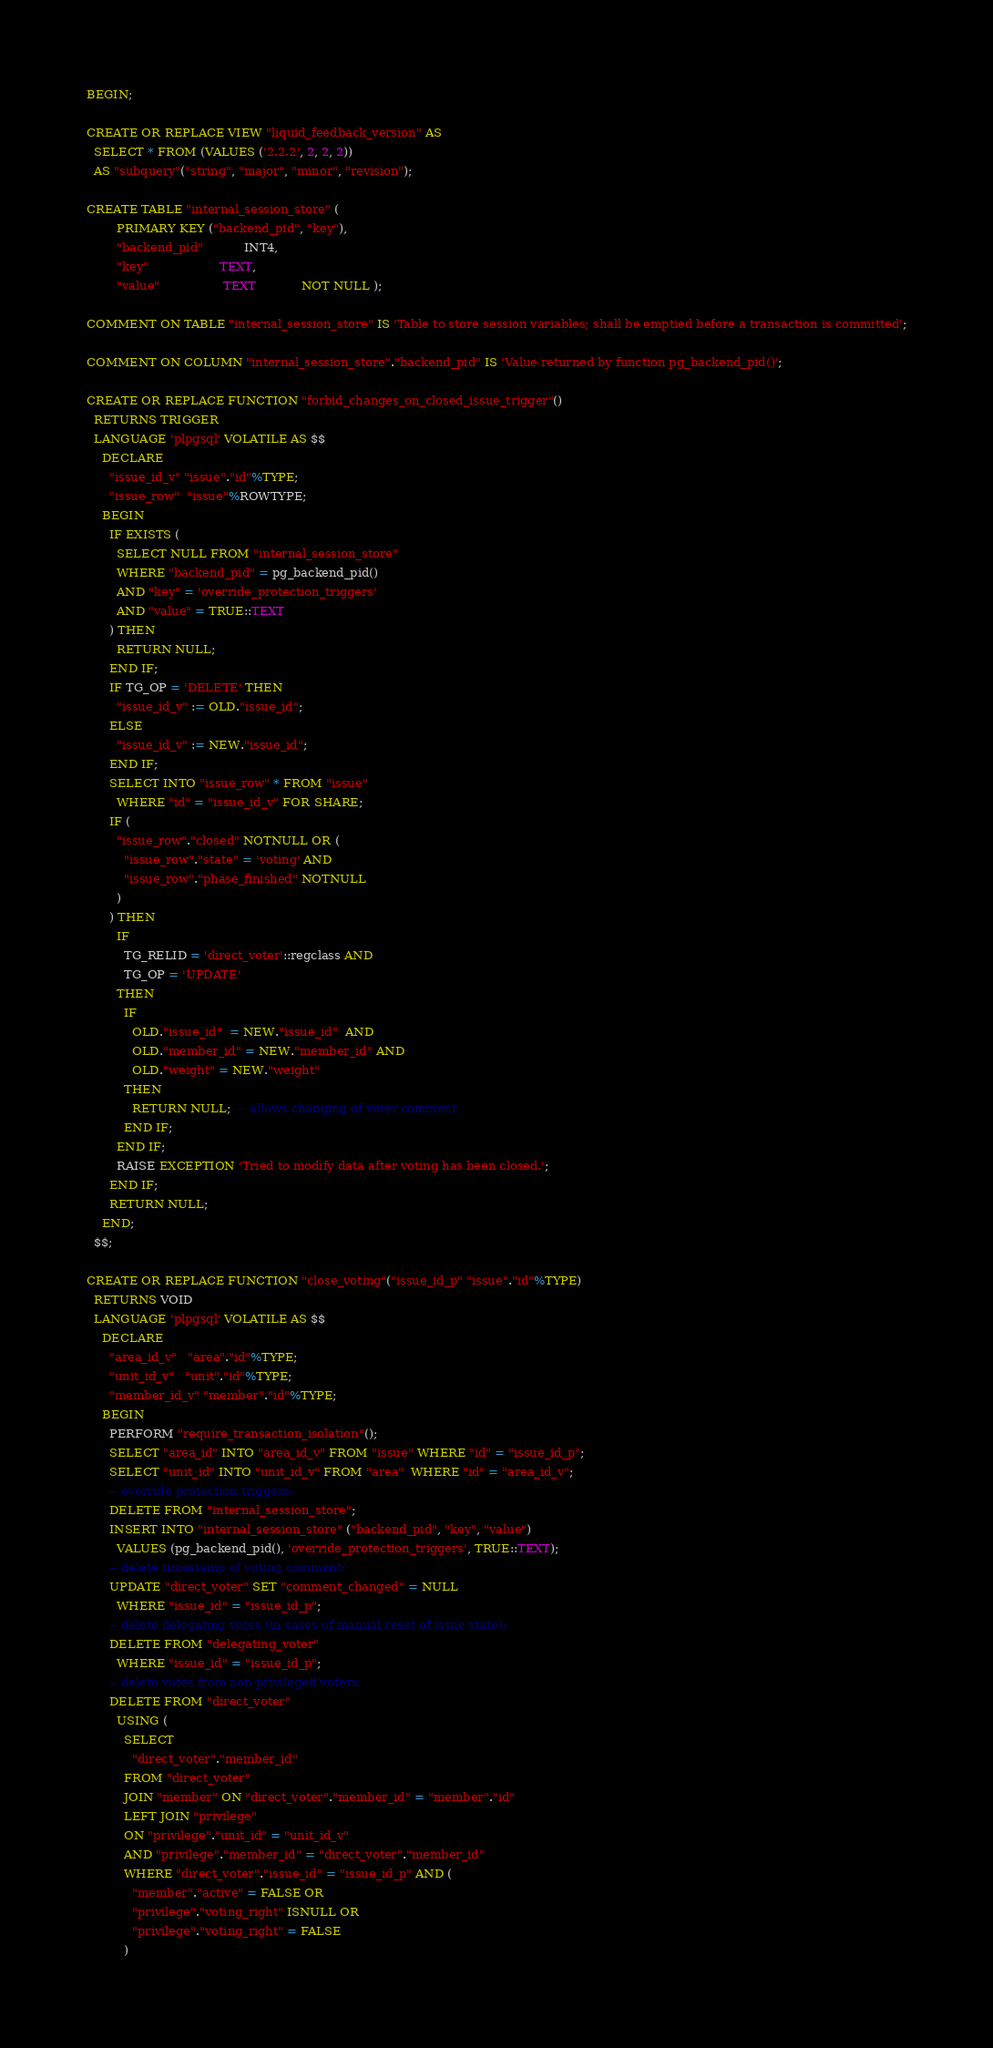<code> <loc_0><loc_0><loc_500><loc_500><_SQL_>BEGIN;

CREATE OR REPLACE VIEW "liquid_feedback_version" AS
  SELECT * FROM (VALUES ('2.2.2', 2, 2, 2))
  AS "subquery"("string", "major", "minor", "revision");

CREATE TABLE "internal_session_store" (
        PRIMARY KEY ("backend_pid", "key"),
        "backend_pid"           INT4,
        "key"                   TEXT,
        "value"                 TEXT            NOT NULL );

COMMENT ON TABLE "internal_session_store" IS 'Table to store session variables; shall be emptied before a transaction is committed';

COMMENT ON COLUMN "internal_session_store"."backend_pid" IS 'Value returned by function pg_backend_pid()';

CREATE OR REPLACE FUNCTION "forbid_changes_on_closed_issue_trigger"()
  RETURNS TRIGGER
  LANGUAGE 'plpgsql' VOLATILE AS $$
    DECLARE
      "issue_id_v" "issue"."id"%TYPE;
      "issue_row"  "issue"%ROWTYPE;
    BEGIN
      IF EXISTS (
        SELECT NULL FROM "internal_session_store"
        WHERE "backend_pid" = pg_backend_pid()
        AND "key" = 'override_protection_triggers'
        AND "value" = TRUE::TEXT
      ) THEN
        RETURN NULL;
      END IF;
      IF TG_OP = 'DELETE' THEN
        "issue_id_v" := OLD."issue_id";
      ELSE
        "issue_id_v" := NEW."issue_id";
      END IF;
      SELECT INTO "issue_row" * FROM "issue"
        WHERE "id" = "issue_id_v" FOR SHARE;
      IF (
        "issue_row"."closed" NOTNULL OR (
          "issue_row"."state" = 'voting' AND
          "issue_row"."phase_finished" NOTNULL
        )
      ) THEN
        IF
          TG_RELID = 'direct_voter'::regclass AND
          TG_OP = 'UPDATE'
        THEN
          IF
            OLD."issue_id"  = NEW."issue_id"  AND
            OLD."member_id" = NEW."member_id" AND
            OLD."weight" = NEW."weight"
          THEN
            RETURN NULL;  -- allows changing of voter comment
          END IF;
        END IF;
        RAISE EXCEPTION 'Tried to modify data after voting has been closed.';
      END IF;
      RETURN NULL;
    END;
  $$;

CREATE OR REPLACE FUNCTION "close_voting"("issue_id_p" "issue"."id"%TYPE)
  RETURNS VOID
  LANGUAGE 'plpgsql' VOLATILE AS $$
    DECLARE
      "area_id_v"   "area"."id"%TYPE;
      "unit_id_v"   "unit"."id"%TYPE;
      "member_id_v" "member"."id"%TYPE;
    BEGIN
      PERFORM "require_transaction_isolation"();
      SELECT "area_id" INTO "area_id_v" FROM "issue" WHERE "id" = "issue_id_p";
      SELECT "unit_id" INTO "unit_id_v" FROM "area"  WHERE "id" = "area_id_v";
      -- override protection triggers:
      DELETE FROM "internal_session_store";
      INSERT INTO "internal_session_store" ("backend_pid", "key", "value")
        VALUES (pg_backend_pid(), 'override_protection_triggers', TRUE::TEXT);
      -- delete timestamp of voting comment:
      UPDATE "direct_voter" SET "comment_changed" = NULL
        WHERE "issue_id" = "issue_id_p";
      -- delete delegating votes (in cases of manual reset of issue state):
      DELETE FROM "delegating_voter"
        WHERE "issue_id" = "issue_id_p";
      -- delete votes from non-privileged voters:
      DELETE FROM "direct_voter"
        USING (
          SELECT
            "direct_voter"."member_id"
          FROM "direct_voter"
          JOIN "member" ON "direct_voter"."member_id" = "member"."id"
          LEFT JOIN "privilege"
          ON "privilege"."unit_id" = "unit_id_v"
          AND "privilege"."member_id" = "direct_voter"."member_id"
          WHERE "direct_voter"."issue_id" = "issue_id_p" AND (
            "member"."active" = FALSE OR
            "privilege"."voting_right" ISNULL OR
            "privilege"."voting_right" = FALSE
          )</code> 